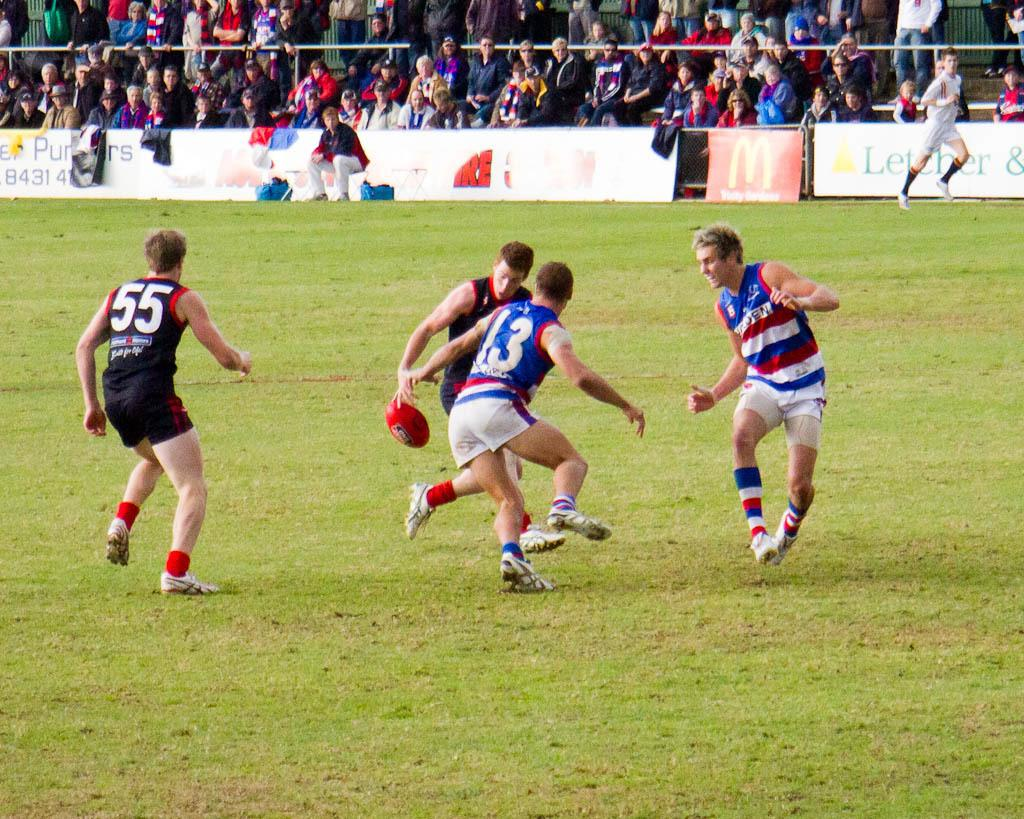<image>
Relay a brief, clear account of the picture shown. Several athletes on a field with jerseys numbered 55 and 13 